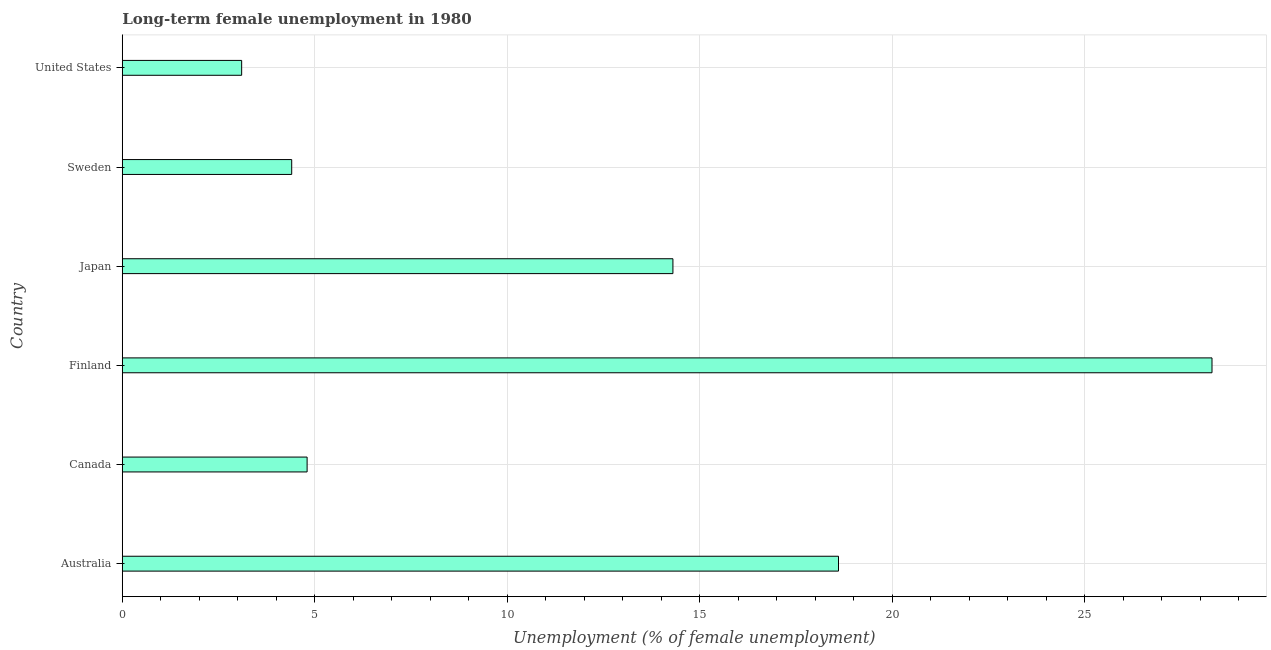Does the graph contain any zero values?
Offer a terse response. No. What is the title of the graph?
Ensure brevity in your answer.  Long-term female unemployment in 1980. What is the label or title of the X-axis?
Your response must be concise. Unemployment (% of female unemployment). What is the label or title of the Y-axis?
Your answer should be very brief. Country. What is the long-term female unemployment in Australia?
Give a very brief answer. 18.6. Across all countries, what is the maximum long-term female unemployment?
Your response must be concise. 28.3. Across all countries, what is the minimum long-term female unemployment?
Offer a very short reply. 3.1. In which country was the long-term female unemployment minimum?
Provide a short and direct response. United States. What is the sum of the long-term female unemployment?
Offer a very short reply. 73.5. What is the difference between the long-term female unemployment in Japan and United States?
Your answer should be compact. 11.2. What is the average long-term female unemployment per country?
Your answer should be compact. 12.25. What is the median long-term female unemployment?
Your response must be concise. 9.55. In how many countries, is the long-term female unemployment greater than 17 %?
Ensure brevity in your answer.  2. What is the ratio of the long-term female unemployment in Sweden to that in United States?
Ensure brevity in your answer.  1.42. Is the sum of the long-term female unemployment in Canada and Sweden greater than the maximum long-term female unemployment across all countries?
Provide a short and direct response. No. What is the difference between the highest and the lowest long-term female unemployment?
Offer a very short reply. 25.2. Are all the bars in the graph horizontal?
Provide a short and direct response. Yes. How many countries are there in the graph?
Make the answer very short. 6. Are the values on the major ticks of X-axis written in scientific E-notation?
Make the answer very short. No. What is the Unemployment (% of female unemployment) of Australia?
Your answer should be very brief. 18.6. What is the Unemployment (% of female unemployment) in Canada?
Keep it short and to the point. 4.8. What is the Unemployment (% of female unemployment) of Finland?
Make the answer very short. 28.3. What is the Unemployment (% of female unemployment) of Japan?
Give a very brief answer. 14.3. What is the Unemployment (% of female unemployment) in Sweden?
Your answer should be very brief. 4.4. What is the Unemployment (% of female unemployment) in United States?
Provide a short and direct response. 3.1. What is the difference between the Unemployment (% of female unemployment) in Australia and Canada?
Offer a very short reply. 13.8. What is the difference between the Unemployment (% of female unemployment) in Australia and Finland?
Your answer should be compact. -9.7. What is the difference between the Unemployment (% of female unemployment) in Australia and Japan?
Make the answer very short. 4.3. What is the difference between the Unemployment (% of female unemployment) in Australia and Sweden?
Provide a short and direct response. 14.2. What is the difference between the Unemployment (% of female unemployment) in Canada and Finland?
Provide a short and direct response. -23.5. What is the difference between the Unemployment (% of female unemployment) in Canada and Japan?
Make the answer very short. -9.5. What is the difference between the Unemployment (% of female unemployment) in Finland and Sweden?
Provide a succinct answer. 23.9. What is the difference between the Unemployment (% of female unemployment) in Finland and United States?
Your answer should be very brief. 25.2. What is the difference between the Unemployment (% of female unemployment) in Japan and Sweden?
Keep it short and to the point. 9.9. What is the difference between the Unemployment (% of female unemployment) in Sweden and United States?
Give a very brief answer. 1.3. What is the ratio of the Unemployment (% of female unemployment) in Australia to that in Canada?
Offer a terse response. 3.88. What is the ratio of the Unemployment (% of female unemployment) in Australia to that in Finland?
Make the answer very short. 0.66. What is the ratio of the Unemployment (% of female unemployment) in Australia to that in Japan?
Your answer should be compact. 1.3. What is the ratio of the Unemployment (% of female unemployment) in Australia to that in Sweden?
Give a very brief answer. 4.23. What is the ratio of the Unemployment (% of female unemployment) in Canada to that in Finland?
Make the answer very short. 0.17. What is the ratio of the Unemployment (% of female unemployment) in Canada to that in Japan?
Keep it short and to the point. 0.34. What is the ratio of the Unemployment (% of female unemployment) in Canada to that in Sweden?
Your answer should be compact. 1.09. What is the ratio of the Unemployment (% of female unemployment) in Canada to that in United States?
Make the answer very short. 1.55. What is the ratio of the Unemployment (% of female unemployment) in Finland to that in Japan?
Ensure brevity in your answer.  1.98. What is the ratio of the Unemployment (% of female unemployment) in Finland to that in Sweden?
Offer a very short reply. 6.43. What is the ratio of the Unemployment (% of female unemployment) in Finland to that in United States?
Your answer should be very brief. 9.13. What is the ratio of the Unemployment (% of female unemployment) in Japan to that in United States?
Keep it short and to the point. 4.61. What is the ratio of the Unemployment (% of female unemployment) in Sweden to that in United States?
Ensure brevity in your answer.  1.42. 